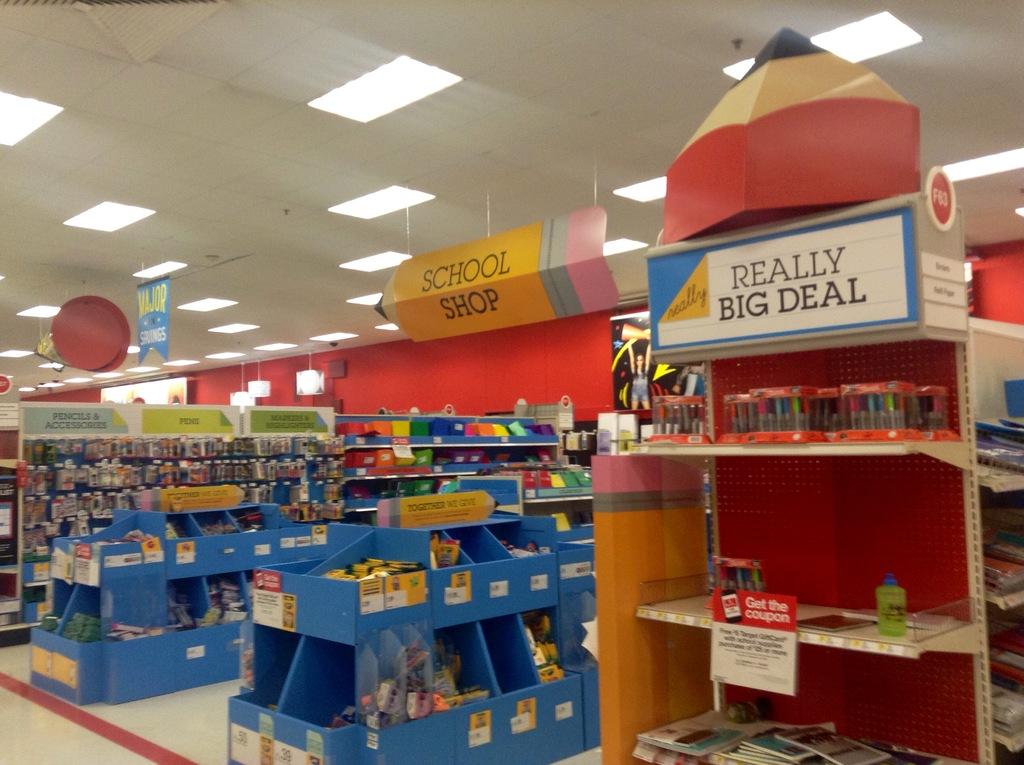What kind of deal is it?
Ensure brevity in your answer.  Really big. Is there a sign for a school shop?
Provide a succinct answer. Yes. 